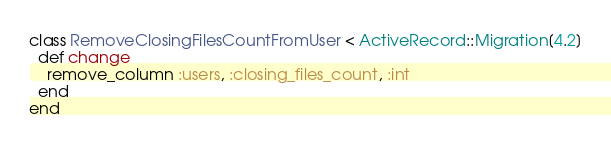Convert code to text. <code><loc_0><loc_0><loc_500><loc_500><_Ruby_>class RemoveClosingFilesCountFromUser < ActiveRecord::Migration[4.2]
  def change
    remove_column :users, :closing_files_count, :int
  end
end
</code> 